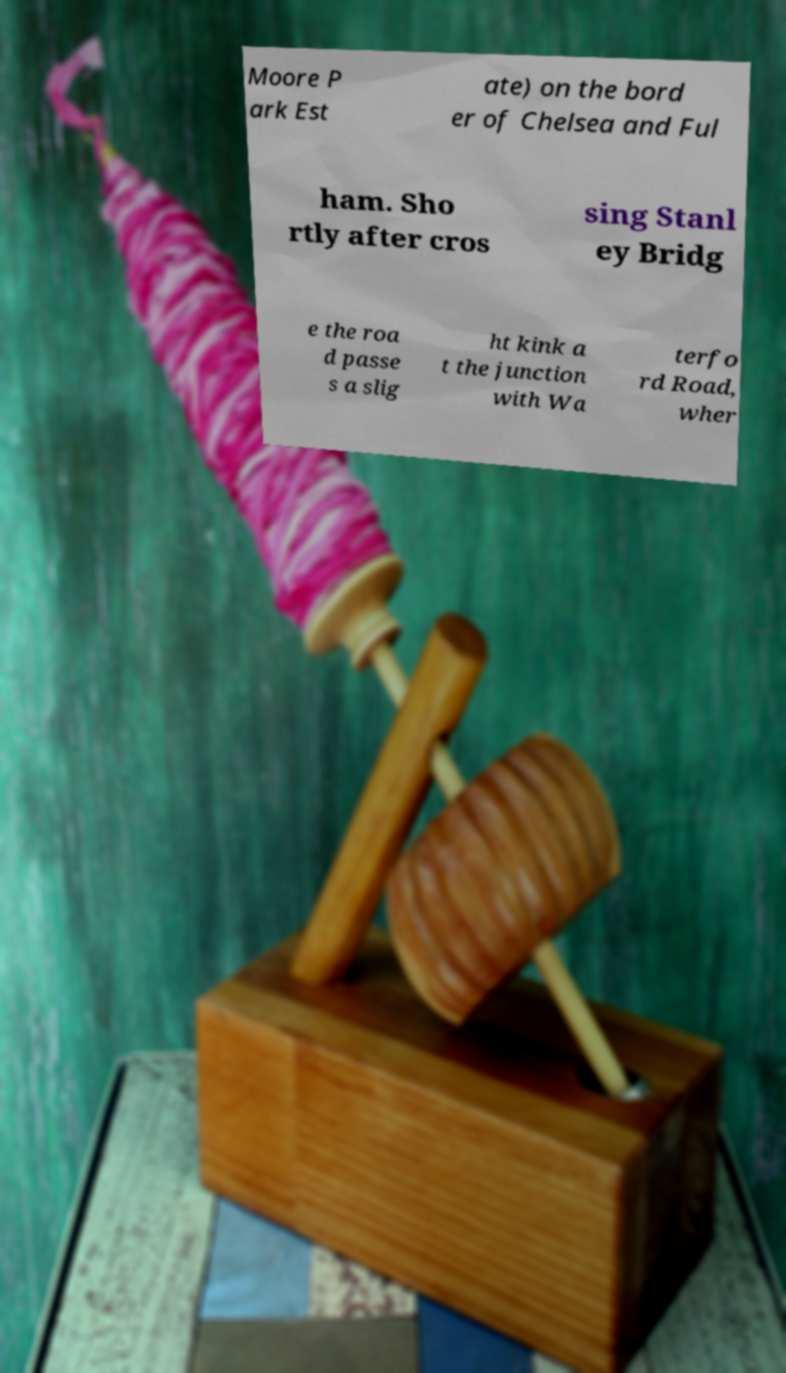There's text embedded in this image that I need extracted. Can you transcribe it verbatim? Moore P ark Est ate) on the bord er of Chelsea and Ful ham. Sho rtly after cros sing Stanl ey Bridg e the roa d passe s a slig ht kink a t the junction with Wa terfo rd Road, wher 